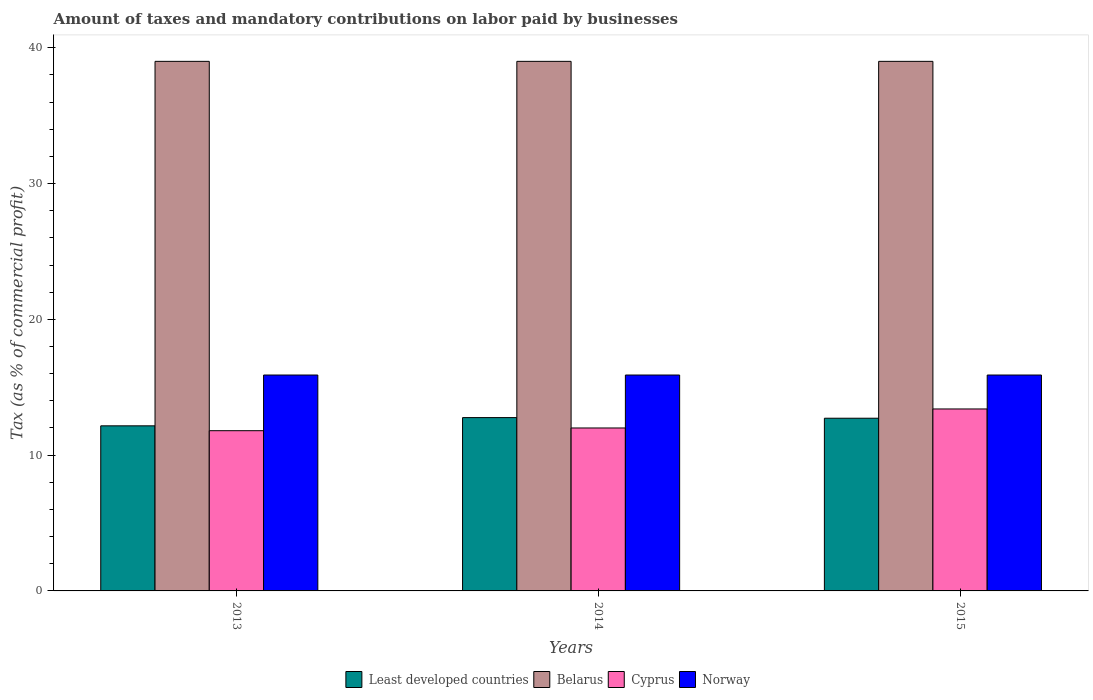Are the number of bars per tick equal to the number of legend labels?
Your answer should be very brief. Yes. Are the number of bars on each tick of the X-axis equal?
Provide a short and direct response. Yes. How many bars are there on the 3rd tick from the left?
Your answer should be compact. 4. How many bars are there on the 3rd tick from the right?
Your answer should be very brief. 4. What is the label of the 1st group of bars from the left?
Provide a short and direct response. 2013. In how many cases, is the number of bars for a given year not equal to the number of legend labels?
Your answer should be compact. 0. Across all years, what is the minimum percentage of taxes paid by businesses in Least developed countries?
Your answer should be compact. 12.16. In which year was the percentage of taxes paid by businesses in Cyprus maximum?
Give a very brief answer. 2015. What is the total percentage of taxes paid by businesses in Norway in the graph?
Provide a succinct answer. 47.7. What is the difference between the percentage of taxes paid by businesses in Least developed countries in 2013 and that in 2015?
Your response must be concise. -0.56. What is the difference between the percentage of taxes paid by businesses in Least developed countries in 2015 and the percentage of taxes paid by businesses in Norway in 2013?
Give a very brief answer. -3.18. What is the average percentage of taxes paid by businesses in Belarus per year?
Offer a terse response. 39. In the year 2013, what is the difference between the percentage of taxes paid by businesses in Belarus and percentage of taxes paid by businesses in Cyprus?
Your answer should be compact. 27.2. In how many years, is the percentage of taxes paid by businesses in Cyprus greater than 36 %?
Provide a succinct answer. 0. What is the ratio of the percentage of taxes paid by businesses in Least developed countries in 2013 to that in 2015?
Provide a short and direct response. 0.96. What is the difference between the highest and the second highest percentage of taxes paid by businesses in Least developed countries?
Keep it short and to the point. 0.05. In how many years, is the percentage of taxes paid by businesses in Belarus greater than the average percentage of taxes paid by businesses in Belarus taken over all years?
Ensure brevity in your answer.  0. Is the sum of the percentage of taxes paid by businesses in Belarus in 2013 and 2015 greater than the maximum percentage of taxes paid by businesses in Least developed countries across all years?
Make the answer very short. Yes. Is it the case that in every year, the sum of the percentage of taxes paid by businesses in Belarus and percentage of taxes paid by businesses in Cyprus is greater than the sum of percentage of taxes paid by businesses in Least developed countries and percentage of taxes paid by businesses in Norway?
Your answer should be very brief. Yes. What does the 4th bar from the left in 2015 represents?
Provide a short and direct response. Norway. What does the 3rd bar from the right in 2014 represents?
Offer a terse response. Belarus. How many bars are there?
Keep it short and to the point. 12. How many years are there in the graph?
Give a very brief answer. 3. Are the values on the major ticks of Y-axis written in scientific E-notation?
Give a very brief answer. No. Does the graph contain any zero values?
Offer a terse response. No. Does the graph contain grids?
Offer a very short reply. No. How many legend labels are there?
Your answer should be compact. 4. What is the title of the graph?
Your response must be concise. Amount of taxes and mandatory contributions on labor paid by businesses. Does "Belgium" appear as one of the legend labels in the graph?
Your answer should be very brief. No. What is the label or title of the X-axis?
Your response must be concise. Years. What is the label or title of the Y-axis?
Your answer should be very brief. Tax (as % of commercial profit). What is the Tax (as % of commercial profit) of Least developed countries in 2013?
Your answer should be very brief. 12.16. What is the Tax (as % of commercial profit) in Belarus in 2013?
Offer a terse response. 39. What is the Tax (as % of commercial profit) in Norway in 2013?
Make the answer very short. 15.9. What is the Tax (as % of commercial profit) in Least developed countries in 2014?
Your answer should be compact. 12.76. What is the Tax (as % of commercial profit) of Belarus in 2014?
Keep it short and to the point. 39. What is the Tax (as % of commercial profit) of Least developed countries in 2015?
Offer a very short reply. 12.72. What is the Tax (as % of commercial profit) in Cyprus in 2015?
Provide a short and direct response. 13.4. What is the Tax (as % of commercial profit) in Norway in 2015?
Make the answer very short. 15.9. Across all years, what is the maximum Tax (as % of commercial profit) of Least developed countries?
Your response must be concise. 12.76. Across all years, what is the maximum Tax (as % of commercial profit) in Belarus?
Make the answer very short. 39. Across all years, what is the maximum Tax (as % of commercial profit) of Cyprus?
Your answer should be very brief. 13.4. Across all years, what is the maximum Tax (as % of commercial profit) in Norway?
Keep it short and to the point. 15.9. Across all years, what is the minimum Tax (as % of commercial profit) of Least developed countries?
Your response must be concise. 12.16. Across all years, what is the minimum Tax (as % of commercial profit) of Belarus?
Your answer should be compact. 39. Across all years, what is the minimum Tax (as % of commercial profit) of Norway?
Make the answer very short. 15.9. What is the total Tax (as % of commercial profit) of Least developed countries in the graph?
Your response must be concise. 37.64. What is the total Tax (as % of commercial profit) of Belarus in the graph?
Your answer should be very brief. 117. What is the total Tax (as % of commercial profit) of Cyprus in the graph?
Make the answer very short. 37.2. What is the total Tax (as % of commercial profit) in Norway in the graph?
Offer a very short reply. 47.7. What is the difference between the Tax (as % of commercial profit) of Least developed countries in 2013 and that in 2014?
Offer a terse response. -0.61. What is the difference between the Tax (as % of commercial profit) of Cyprus in 2013 and that in 2014?
Provide a succinct answer. -0.2. What is the difference between the Tax (as % of commercial profit) in Least developed countries in 2013 and that in 2015?
Offer a very short reply. -0.56. What is the difference between the Tax (as % of commercial profit) in Belarus in 2013 and that in 2015?
Provide a succinct answer. 0. What is the difference between the Tax (as % of commercial profit) of Cyprus in 2013 and that in 2015?
Offer a terse response. -1.6. What is the difference between the Tax (as % of commercial profit) in Least developed countries in 2014 and that in 2015?
Give a very brief answer. 0.05. What is the difference between the Tax (as % of commercial profit) in Belarus in 2014 and that in 2015?
Keep it short and to the point. 0. What is the difference between the Tax (as % of commercial profit) of Norway in 2014 and that in 2015?
Provide a succinct answer. 0. What is the difference between the Tax (as % of commercial profit) in Least developed countries in 2013 and the Tax (as % of commercial profit) in Belarus in 2014?
Make the answer very short. -26.84. What is the difference between the Tax (as % of commercial profit) of Least developed countries in 2013 and the Tax (as % of commercial profit) of Cyprus in 2014?
Ensure brevity in your answer.  0.16. What is the difference between the Tax (as % of commercial profit) in Least developed countries in 2013 and the Tax (as % of commercial profit) in Norway in 2014?
Offer a terse response. -3.74. What is the difference between the Tax (as % of commercial profit) in Belarus in 2013 and the Tax (as % of commercial profit) in Cyprus in 2014?
Offer a very short reply. 27. What is the difference between the Tax (as % of commercial profit) in Belarus in 2013 and the Tax (as % of commercial profit) in Norway in 2014?
Your answer should be compact. 23.1. What is the difference between the Tax (as % of commercial profit) of Least developed countries in 2013 and the Tax (as % of commercial profit) of Belarus in 2015?
Offer a very short reply. -26.84. What is the difference between the Tax (as % of commercial profit) of Least developed countries in 2013 and the Tax (as % of commercial profit) of Cyprus in 2015?
Give a very brief answer. -1.24. What is the difference between the Tax (as % of commercial profit) of Least developed countries in 2013 and the Tax (as % of commercial profit) of Norway in 2015?
Keep it short and to the point. -3.74. What is the difference between the Tax (as % of commercial profit) of Belarus in 2013 and the Tax (as % of commercial profit) of Cyprus in 2015?
Keep it short and to the point. 25.6. What is the difference between the Tax (as % of commercial profit) of Belarus in 2013 and the Tax (as % of commercial profit) of Norway in 2015?
Offer a very short reply. 23.1. What is the difference between the Tax (as % of commercial profit) of Cyprus in 2013 and the Tax (as % of commercial profit) of Norway in 2015?
Give a very brief answer. -4.1. What is the difference between the Tax (as % of commercial profit) of Least developed countries in 2014 and the Tax (as % of commercial profit) of Belarus in 2015?
Give a very brief answer. -26.24. What is the difference between the Tax (as % of commercial profit) of Least developed countries in 2014 and the Tax (as % of commercial profit) of Cyprus in 2015?
Provide a short and direct response. -0.64. What is the difference between the Tax (as % of commercial profit) of Least developed countries in 2014 and the Tax (as % of commercial profit) of Norway in 2015?
Keep it short and to the point. -3.14. What is the difference between the Tax (as % of commercial profit) in Belarus in 2014 and the Tax (as % of commercial profit) in Cyprus in 2015?
Ensure brevity in your answer.  25.6. What is the difference between the Tax (as % of commercial profit) of Belarus in 2014 and the Tax (as % of commercial profit) of Norway in 2015?
Keep it short and to the point. 23.1. What is the difference between the Tax (as % of commercial profit) of Cyprus in 2014 and the Tax (as % of commercial profit) of Norway in 2015?
Offer a very short reply. -3.9. What is the average Tax (as % of commercial profit) in Least developed countries per year?
Make the answer very short. 12.55. What is the average Tax (as % of commercial profit) of Norway per year?
Provide a short and direct response. 15.9. In the year 2013, what is the difference between the Tax (as % of commercial profit) of Least developed countries and Tax (as % of commercial profit) of Belarus?
Make the answer very short. -26.84. In the year 2013, what is the difference between the Tax (as % of commercial profit) of Least developed countries and Tax (as % of commercial profit) of Cyprus?
Your answer should be very brief. 0.36. In the year 2013, what is the difference between the Tax (as % of commercial profit) in Least developed countries and Tax (as % of commercial profit) in Norway?
Ensure brevity in your answer.  -3.74. In the year 2013, what is the difference between the Tax (as % of commercial profit) of Belarus and Tax (as % of commercial profit) of Cyprus?
Your answer should be compact. 27.2. In the year 2013, what is the difference between the Tax (as % of commercial profit) of Belarus and Tax (as % of commercial profit) of Norway?
Make the answer very short. 23.1. In the year 2014, what is the difference between the Tax (as % of commercial profit) of Least developed countries and Tax (as % of commercial profit) of Belarus?
Your answer should be very brief. -26.24. In the year 2014, what is the difference between the Tax (as % of commercial profit) in Least developed countries and Tax (as % of commercial profit) in Cyprus?
Offer a terse response. 0.76. In the year 2014, what is the difference between the Tax (as % of commercial profit) of Least developed countries and Tax (as % of commercial profit) of Norway?
Offer a very short reply. -3.14. In the year 2014, what is the difference between the Tax (as % of commercial profit) in Belarus and Tax (as % of commercial profit) in Cyprus?
Your answer should be compact. 27. In the year 2014, what is the difference between the Tax (as % of commercial profit) in Belarus and Tax (as % of commercial profit) in Norway?
Make the answer very short. 23.1. In the year 2014, what is the difference between the Tax (as % of commercial profit) of Cyprus and Tax (as % of commercial profit) of Norway?
Make the answer very short. -3.9. In the year 2015, what is the difference between the Tax (as % of commercial profit) of Least developed countries and Tax (as % of commercial profit) of Belarus?
Offer a very short reply. -26.28. In the year 2015, what is the difference between the Tax (as % of commercial profit) in Least developed countries and Tax (as % of commercial profit) in Cyprus?
Provide a short and direct response. -0.68. In the year 2015, what is the difference between the Tax (as % of commercial profit) in Least developed countries and Tax (as % of commercial profit) in Norway?
Make the answer very short. -3.18. In the year 2015, what is the difference between the Tax (as % of commercial profit) of Belarus and Tax (as % of commercial profit) of Cyprus?
Your response must be concise. 25.6. In the year 2015, what is the difference between the Tax (as % of commercial profit) of Belarus and Tax (as % of commercial profit) of Norway?
Provide a succinct answer. 23.1. What is the ratio of the Tax (as % of commercial profit) in Least developed countries in 2013 to that in 2014?
Your answer should be compact. 0.95. What is the ratio of the Tax (as % of commercial profit) in Cyprus in 2013 to that in 2014?
Your answer should be compact. 0.98. What is the ratio of the Tax (as % of commercial profit) of Norway in 2013 to that in 2014?
Provide a short and direct response. 1. What is the ratio of the Tax (as % of commercial profit) of Least developed countries in 2013 to that in 2015?
Your response must be concise. 0.96. What is the ratio of the Tax (as % of commercial profit) in Belarus in 2013 to that in 2015?
Provide a succinct answer. 1. What is the ratio of the Tax (as % of commercial profit) in Cyprus in 2013 to that in 2015?
Offer a terse response. 0.88. What is the ratio of the Tax (as % of commercial profit) in Norway in 2013 to that in 2015?
Make the answer very short. 1. What is the ratio of the Tax (as % of commercial profit) of Least developed countries in 2014 to that in 2015?
Offer a very short reply. 1. What is the ratio of the Tax (as % of commercial profit) of Belarus in 2014 to that in 2015?
Offer a very short reply. 1. What is the ratio of the Tax (as % of commercial profit) of Cyprus in 2014 to that in 2015?
Offer a terse response. 0.9. What is the ratio of the Tax (as % of commercial profit) in Norway in 2014 to that in 2015?
Provide a short and direct response. 1. What is the difference between the highest and the second highest Tax (as % of commercial profit) in Least developed countries?
Provide a short and direct response. 0.05. What is the difference between the highest and the second highest Tax (as % of commercial profit) in Cyprus?
Keep it short and to the point. 1.4. What is the difference between the highest and the second highest Tax (as % of commercial profit) in Norway?
Provide a succinct answer. 0. What is the difference between the highest and the lowest Tax (as % of commercial profit) of Least developed countries?
Offer a terse response. 0.61. What is the difference between the highest and the lowest Tax (as % of commercial profit) of Cyprus?
Ensure brevity in your answer.  1.6. What is the difference between the highest and the lowest Tax (as % of commercial profit) in Norway?
Make the answer very short. 0. 